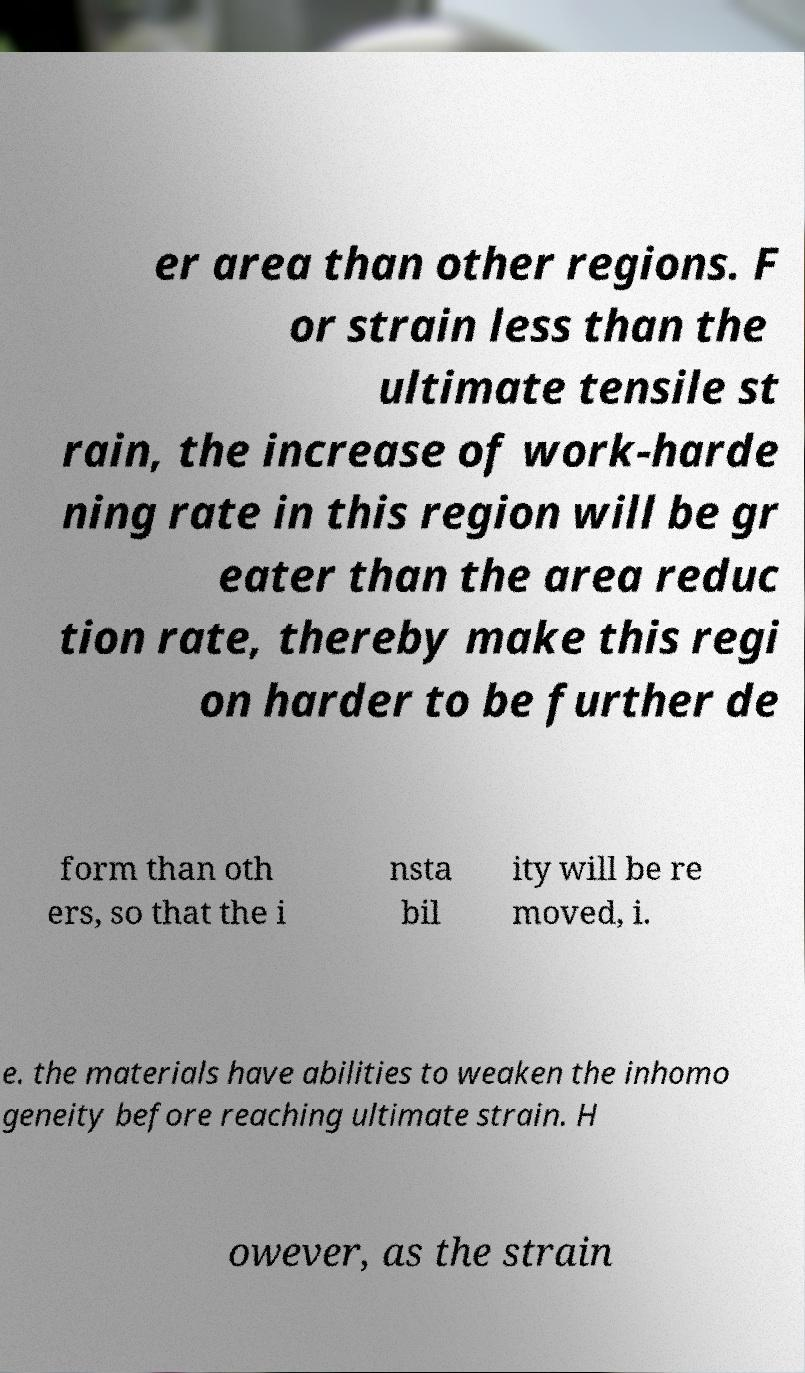Could you assist in decoding the text presented in this image and type it out clearly? er area than other regions. F or strain less than the ultimate tensile st rain, the increase of work-harde ning rate in this region will be gr eater than the area reduc tion rate, thereby make this regi on harder to be further de form than oth ers, so that the i nsta bil ity will be re moved, i. e. the materials have abilities to weaken the inhomo geneity before reaching ultimate strain. H owever, as the strain 